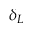Convert formula to latex. <formula><loc_0><loc_0><loc_500><loc_500>\delta _ { L }</formula> 